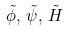Convert formula to latex. <formula><loc_0><loc_0><loc_500><loc_500>\tilde { \phi } , \, \tilde { \psi } , \, \tilde { H }</formula> 